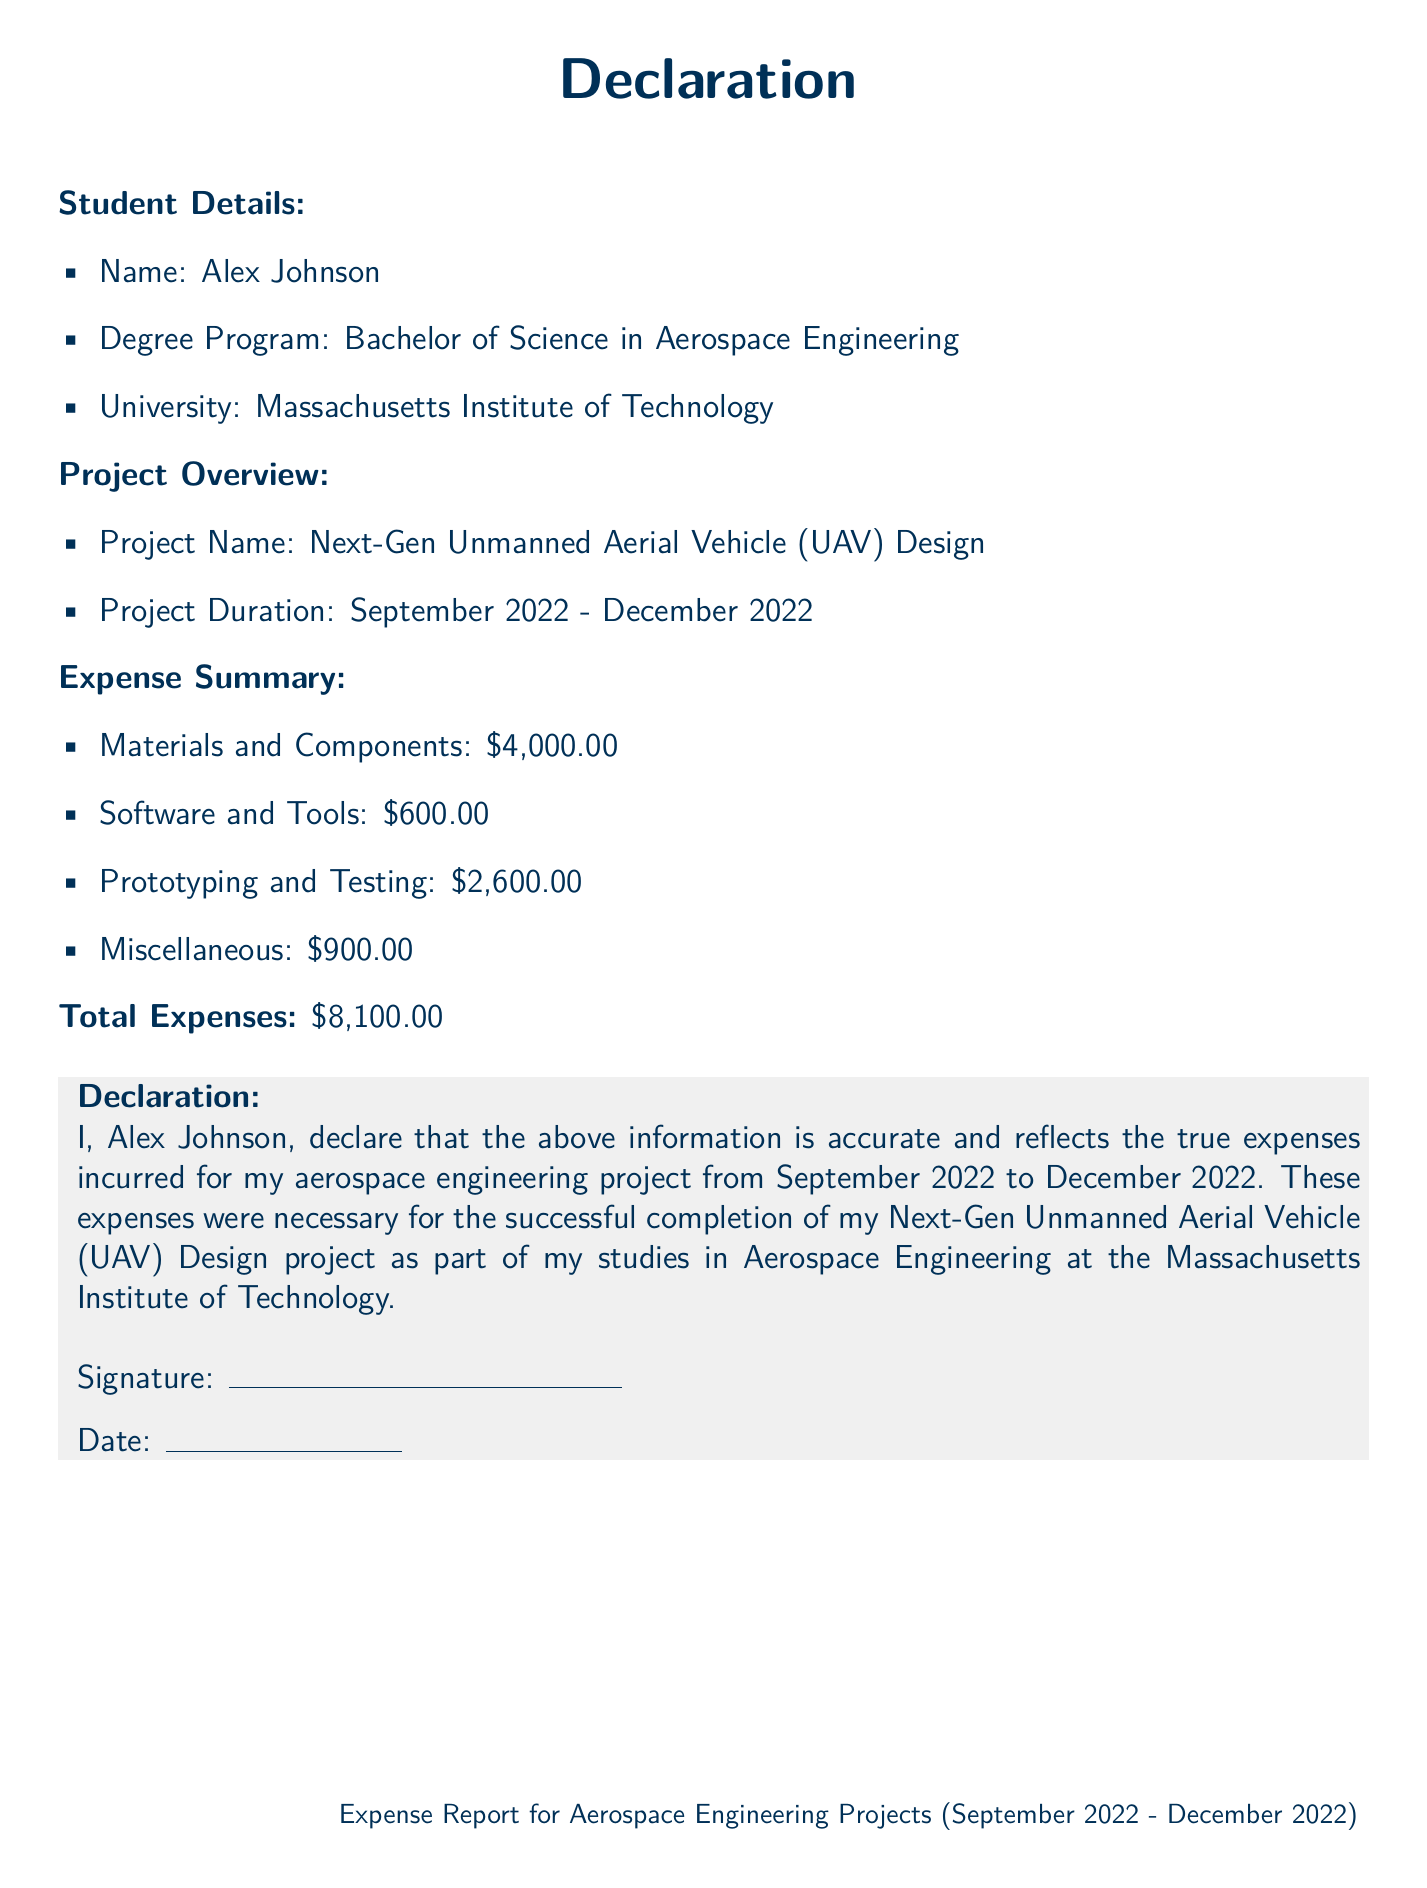What is the name of the student? The student's name is provided in the document under "Student Details."
Answer: Alex Johnson What is the project name? The project name is specified in the "Project Overview" section of the document.
Answer: Next-Gen Unmanned Aerial Vehicle (UAV) Design What are the total expenses? The total expenses can be found in the "Expense Summary" section, where all costs are summed up.
Answer: $8,100.00 How much was spent on Materials and Components? The amount for Materials and Components is detailed in the "Expense Summary."
Answer: $4,000.00 During which months did the project take place? The project duration is indicated in the "Project Overview" section.
Answer: September 2022 - December 2022 Who is the authorized signatory? The declaration includes the name of the individual declaring the expenses.
Answer: Alex Johnson What university is the student attending? This information is mentioned under "Student Details" in the document.
Answer: Massachusetts Institute of Technology What category has the highest expense? By analyzing the "Expense Summary," you can identify which expense category costs the most.
Answer: Materials and Components What is the date format used in the declaration? The declaration's date fields suggest a standard date format.
Answer: Day/Month/Year 